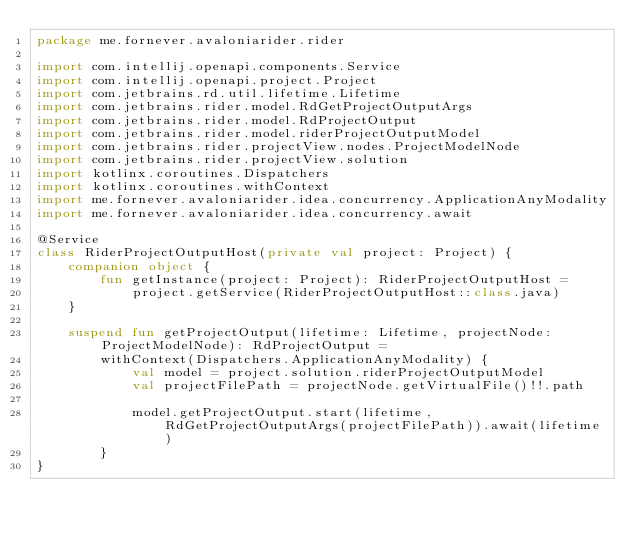Convert code to text. <code><loc_0><loc_0><loc_500><loc_500><_Kotlin_>package me.fornever.avaloniarider.rider

import com.intellij.openapi.components.Service
import com.intellij.openapi.project.Project
import com.jetbrains.rd.util.lifetime.Lifetime
import com.jetbrains.rider.model.RdGetProjectOutputArgs
import com.jetbrains.rider.model.RdProjectOutput
import com.jetbrains.rider.model.riderProjectOutputModel
import com.jetbrains.rider.projectView.nodes.ProjectModelNode
import com.jetbrains.rider.projectView.solution
import kotlinx.coroutines.Dispatchers
import kotlinx.coroutines.withContext
import me.fornever.avaloniarider.idea.concurrency.ApplicationAnyModality
import me.fornever.avaloniarider.idea.concurrency.await

@Service
class RiderProjectOutputHost(private val project: Project) {
    companion object {
        fun getInstance(project: Project): RiderProjectOutputHost =
            project.getService(RiderProjectOutputHost::class.java)
    }

    suspend fun getProjectOutput(lifetime: Lifetime, projectNode: ProjectModelNode): RdProjectOutput =
        withContext(Dispatchers.ApplicationAnyModality) {
            val model = project.solution.riderProjectOutputModel
            val projectFilePath = projectNode.getVirtualFile()!!.path

            model.getProjectOutput.start(lifetime, RdGetProjectOutputArgs(projectFilePath)).await(lifetime)
        }
}
</code> 